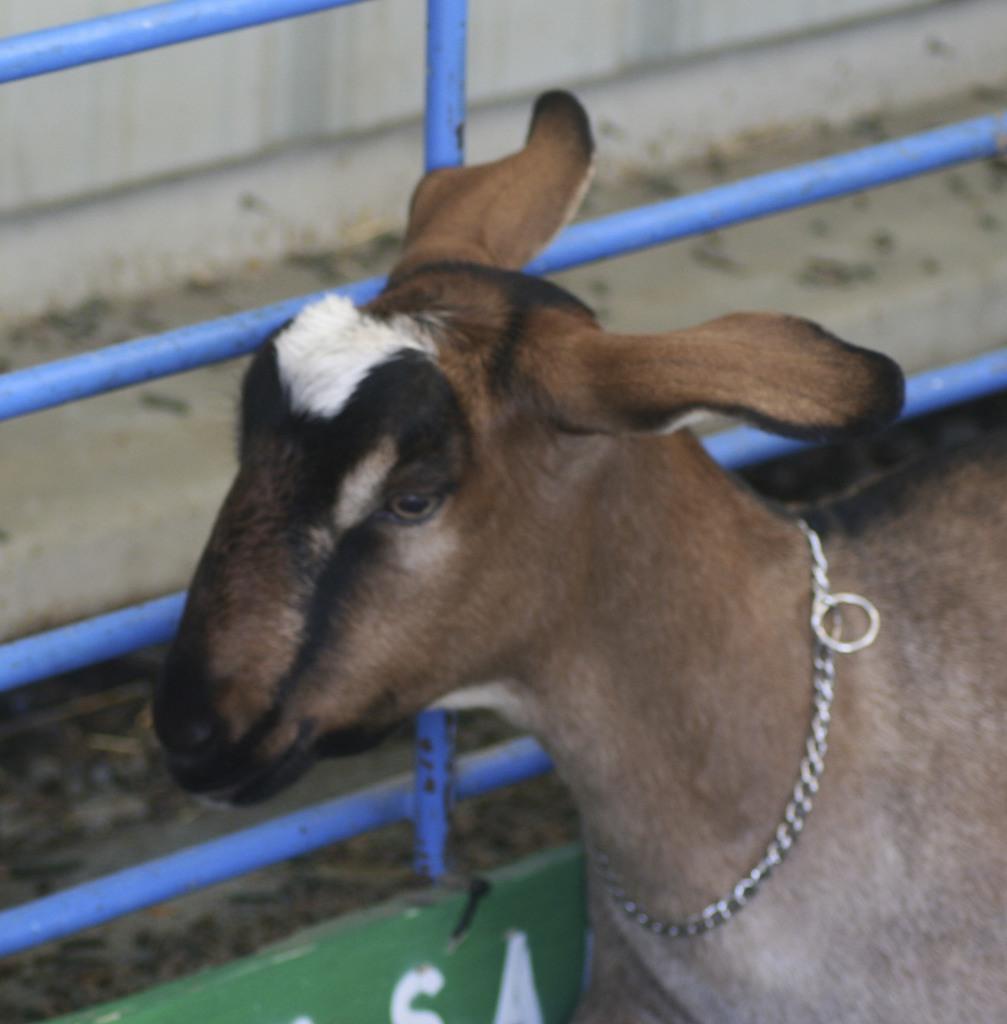In one or two sentences, can you explain what this image depicts? This image consists of a goat. It has a belt. It is in brown color. 